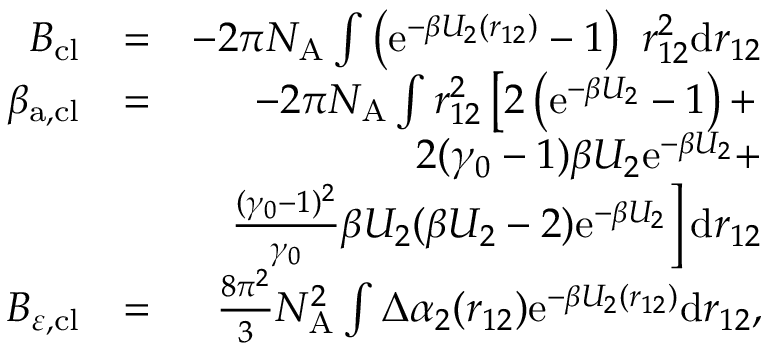Convert formula to latex. <formula><loc_0><loc_0><loc_500><loc_500>\begin{array} { r l r } { B _ { c l } } & { = } & { - 2 \pi N _ { A } \int \left ( e ^ { - \beta U _ { 2 } ( r _ { 1 2 } ) } - 1 \right ) r _ { 1 2 } ^ { 2 } d r _ { 1 2 } } \\ { \beta _ { a , c l } } & { = } & { - 2 \pi N _ { A } \int r _ { 1 2 } ^ { 2 } \left [ 2 \left ( e ^ { - \beta U _ { 2 } } - 1 \right ) + } \\ & { 2 ( \gamma _ { 0 } - 1 ) \beta U _ { 2 } e ^ { - \beta U _ { 2 } } + } \\ & { \frac { ( \gamma _ { 0 } - 1 ) ^ { 2 } } { \gamma _ { 0 } } \beta U _ { 2 } ( \beta U _ { 2 } - 2 ) e ^ { - \beta U _ { 2 } } \right ] d r _ { 1 2 } } \\ { B _ { \varepsilon , c l } } & { = } & { \frac { 8 \pi ^ { 2 } } { 3 } N _ { A } ^ { 2 } \int \Delta \alpha _ { 2 } ( r _ { 1 2 } ) e ^ { - \beta U _ { 2 } ( r _ { 1 2 } ) } d r _ { 1 2 } , } \end{array}</formula> 